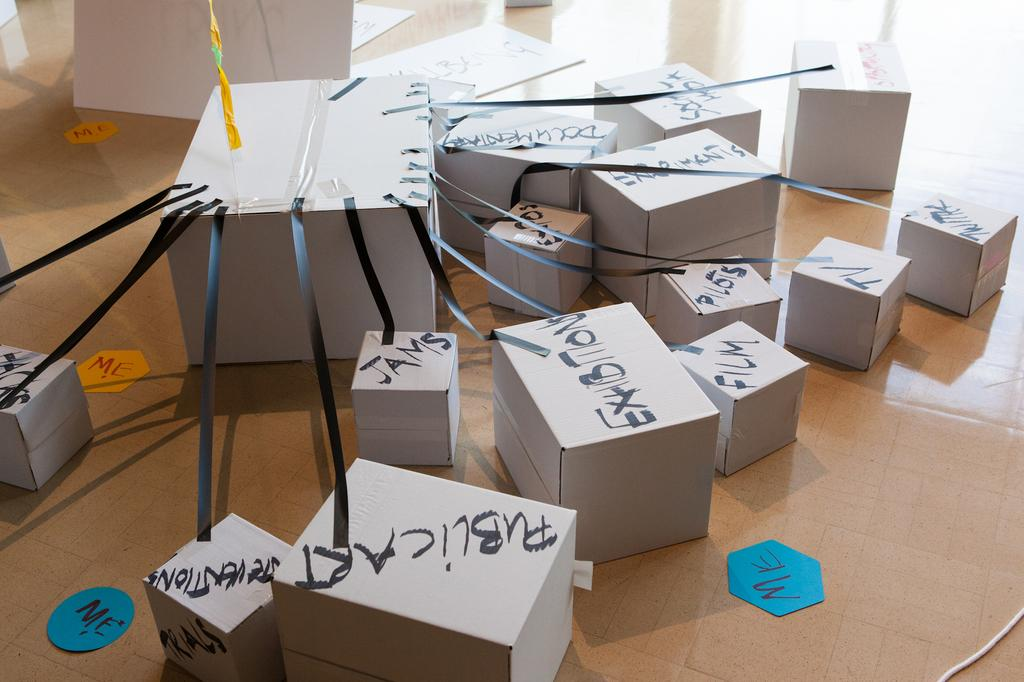<image>
Write a terse but informative summary of the picture. alot of white boxes on the ground with black lettering on them with one of them saying 'public art' 